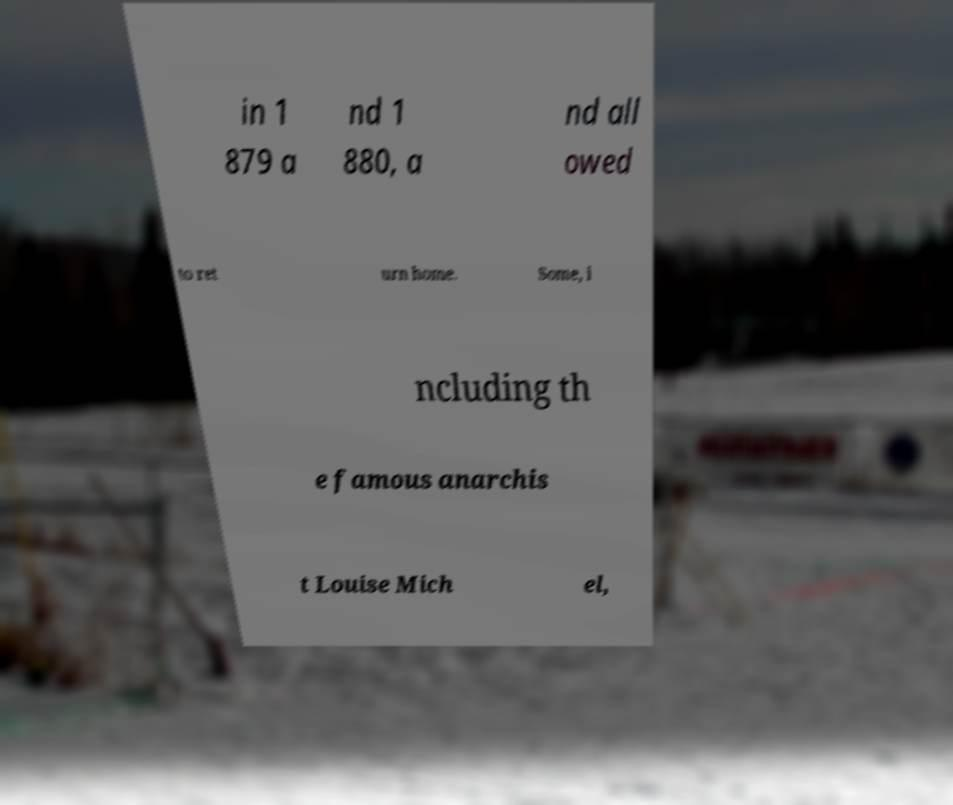Can you read and provide the text displayed in the image?This photo seems to have some interesting text. Can you extract and type it out for me? in 1 879 a nd 1 880, a nd all owed to ret urn home. Some, i ncluding th e famous anarchis t Louise Mich el, 